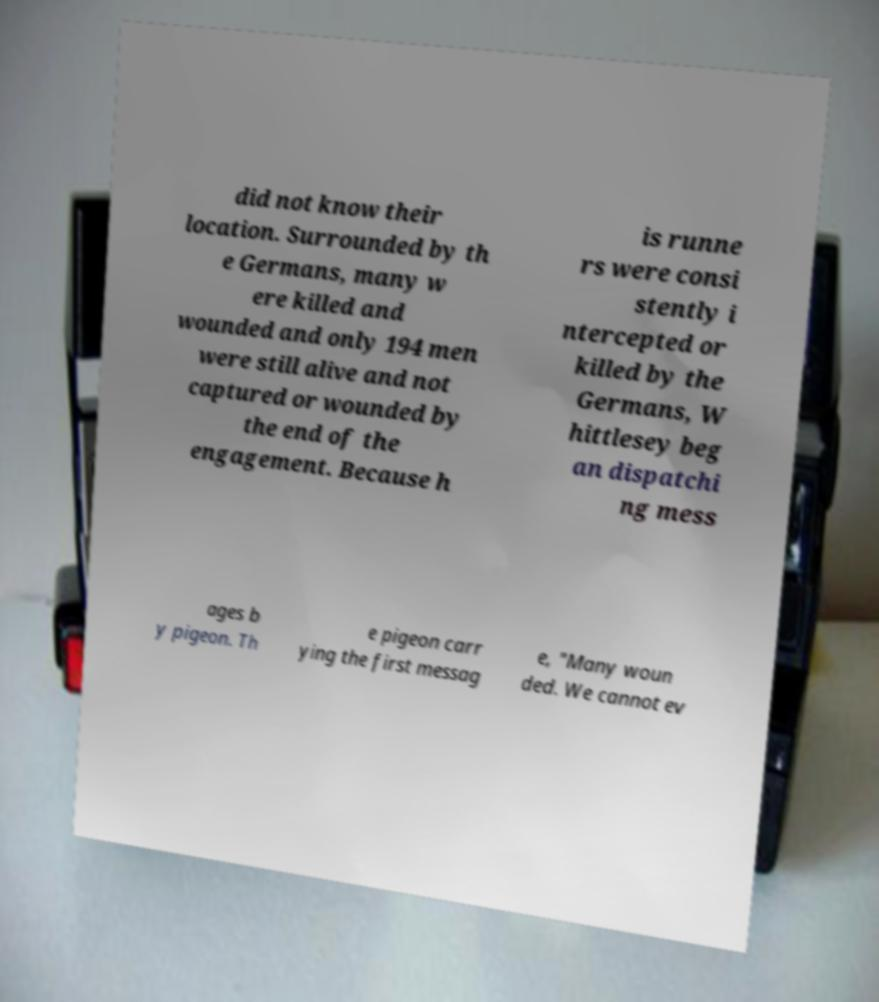What messages or text are displayed in this image? I need them in a readable, typed format. did not know their location. Surrounded by th e Germans, many w ere killed and wounded and only 194 men were still alive and not captured or wounded by the end of the engagement. Because h is runne rs were consi stently i ntercepted or killed by the Germans, W hittlesey beg an dispatchi ng mess ages b y pigeon. Th e pigeon carr ying the first messag e, "Many woun ded. We cannot ev 